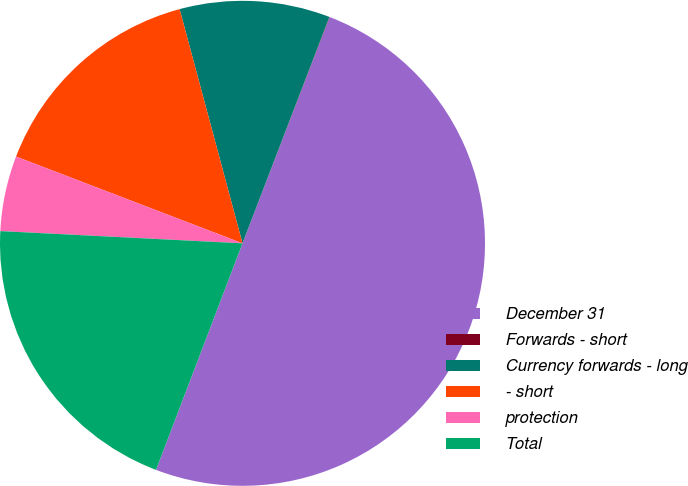<chart> <loc_0><loc_0><loc_500><loc_500><pie_chart><fcel>December 31<fcel>Forwards - short<fcel>Currency forwards - long<fcel>- short<fcel>protection<fcel>Total<nl><fcel>49.95%<fcel>0.02%<fcel>10.01%<fcel>15.0%<fcel>5.02%<fcel>20.0%<nl></chart> 